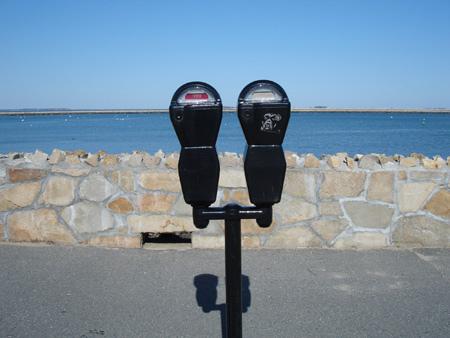What color is the water?
Short answer required. Blue. Is there still time on both the meters?
Keep it brief. No. Do you have to pay to park?
Quick response, please. Yes. 